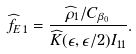Convert formula to latex. <formula><loc_0><loc_0><loc_500><loc_500>\widehat { f } _ { E \, 1 } = \frac { \widehat { \rho } _ { 1 } / C _ { \beta _ { 0 } } } { \widehat { K } ( \epsilon , \epsilon / 2 ) I _ { 1 1 } } .</formula> 